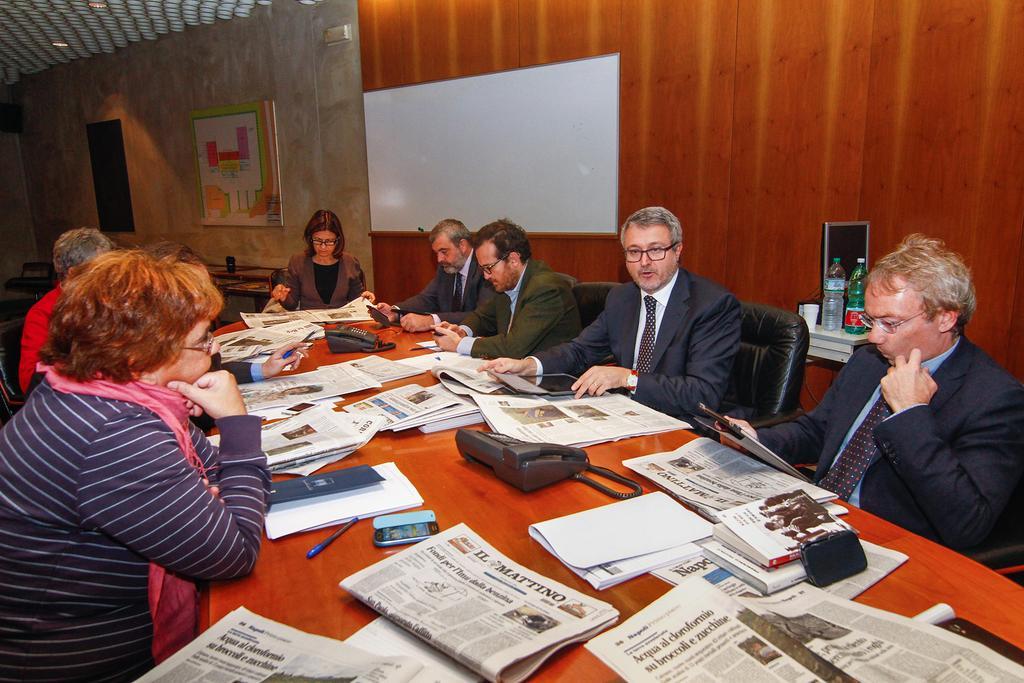In one or two sentences, can you explain what this image depicts? In this image we can see these people are sitting on the chairs near the table where newspapers, books, telephones, mobile phone, pen and a few more things kept. Here we can see bottles and cups kept. Here we can see a board to the wooden wall and in the background, we can see a frame on the wall. 